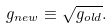Convert formula to latex. <formula><loc_0><loc_0><loc_500><loc_500>g _ { n e w } \equiv \sqrt { g _ { o l d } } .</formula> 